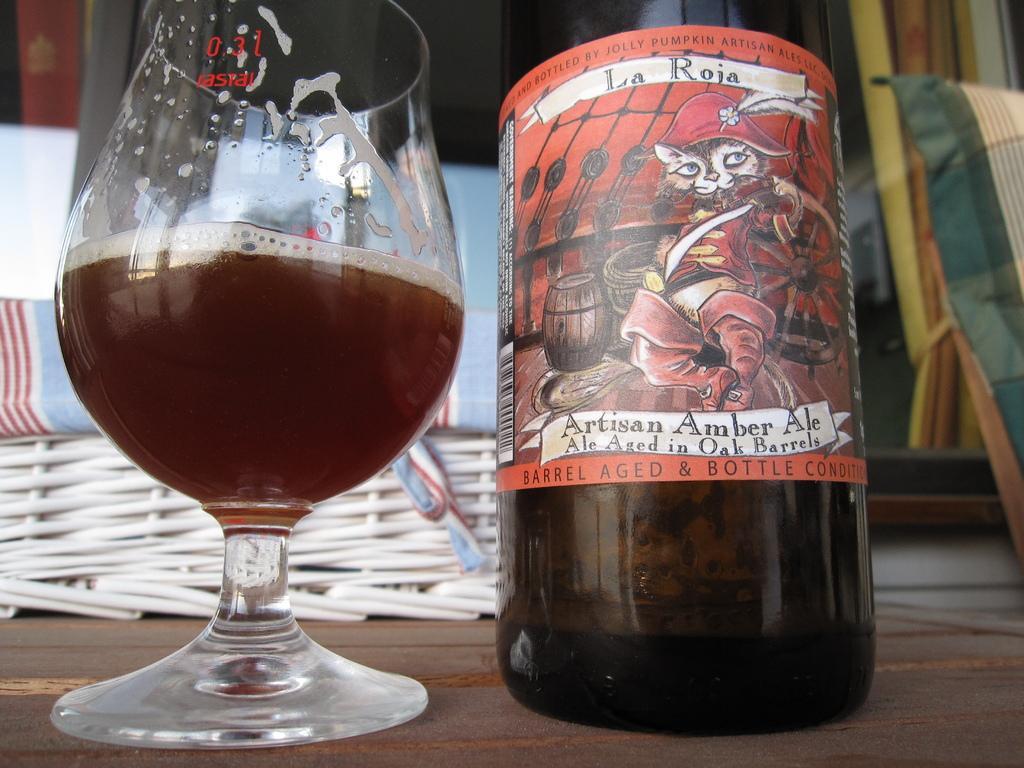Could you give a brief overview of what you see in this image? In this picture we can see a glass with drink in it, and a bottle. 